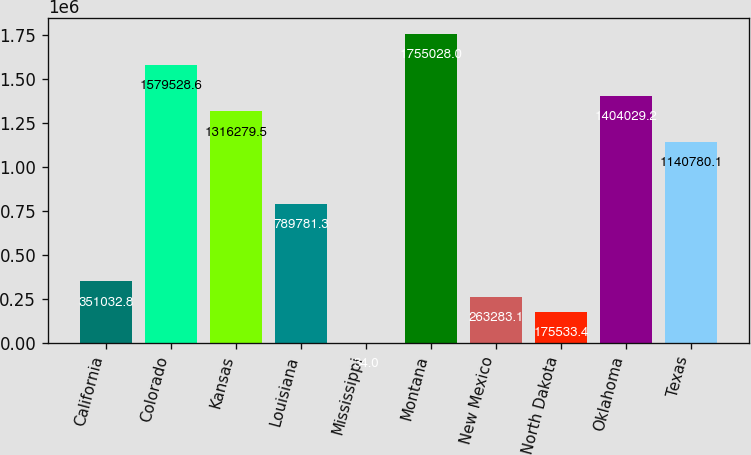Convert chart to OTSL. <chart><loc_0><loc_0><loc_500><loc_500><bar_chart><fcel>California<fcel>Colorado<fcel>Kansas<fcel>Louisiana<fcel>Mississippi<fcel>Montana<fcel>New Mexico<fcel>North Dakota<fcel>Oklahoma<fcel>Texas<nl><fcel>351033<fcel>1.57953e+06<fcel>1.31628e+06<fcel>789781<fcel>34<fcel>1.75503e+06<fcel>263283<fcel>175533<fcel>1.40403e+06<fcel>1.14078e+06<nl></chart> 